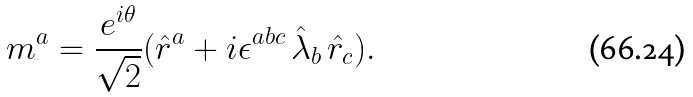<formula> <loc_0><loc_0><loc_500><loc_500>m ^ { a } = { \frac { e ^ { i \theta } } { \sqrt { 2 } } } ( \hat { r } ^ { a } + i \epsilon ^ { a b c } \, \hat { \lambda } _ { b } \, \hat { r } _ { c } ) .</formula> 